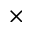<formula> <loc_0><loc_0><loc_500><loc_500>\times</formula> 